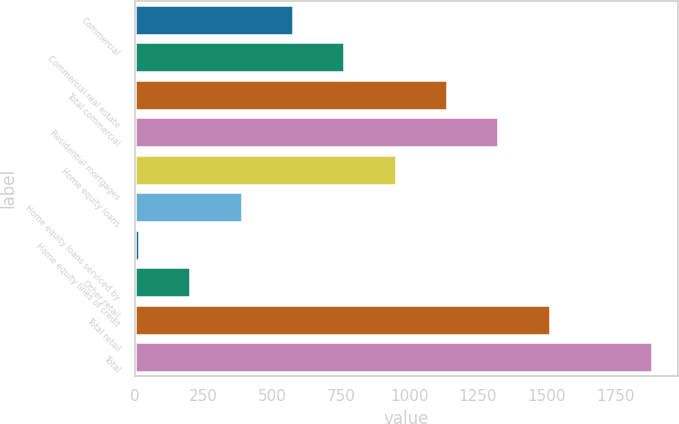Convert chart. <chart><loc_0><loc_0><loc_500><loc_500><bar_chart><fcel>Commercial<fcel>Commercial real estate<fcel>Total commercial<fcel>Residential mortgages<fcel>Home equity loans<fcel>Home equity loans serviced by<fcel>Home equity lines of credit<fcel>Other retail<fcel>Total retail<fcel>Total<nl><fcel>576<fcel>763<fcel>1137<fcel>1324<fcel>950<fcel>389<fcel>15<fcel>202<fcel>1511<fcel>1885<nl></chart> 